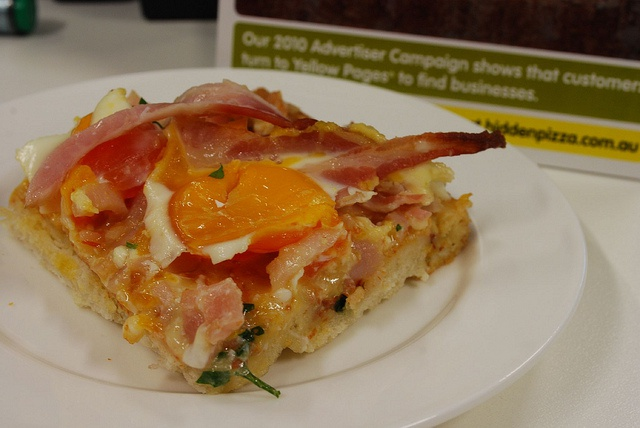Describe the objects in this image and their specific colors. I can see pizza in darkgray, brown, tan, and maroon tones and dining table in darkgray and gray tones in this image. 